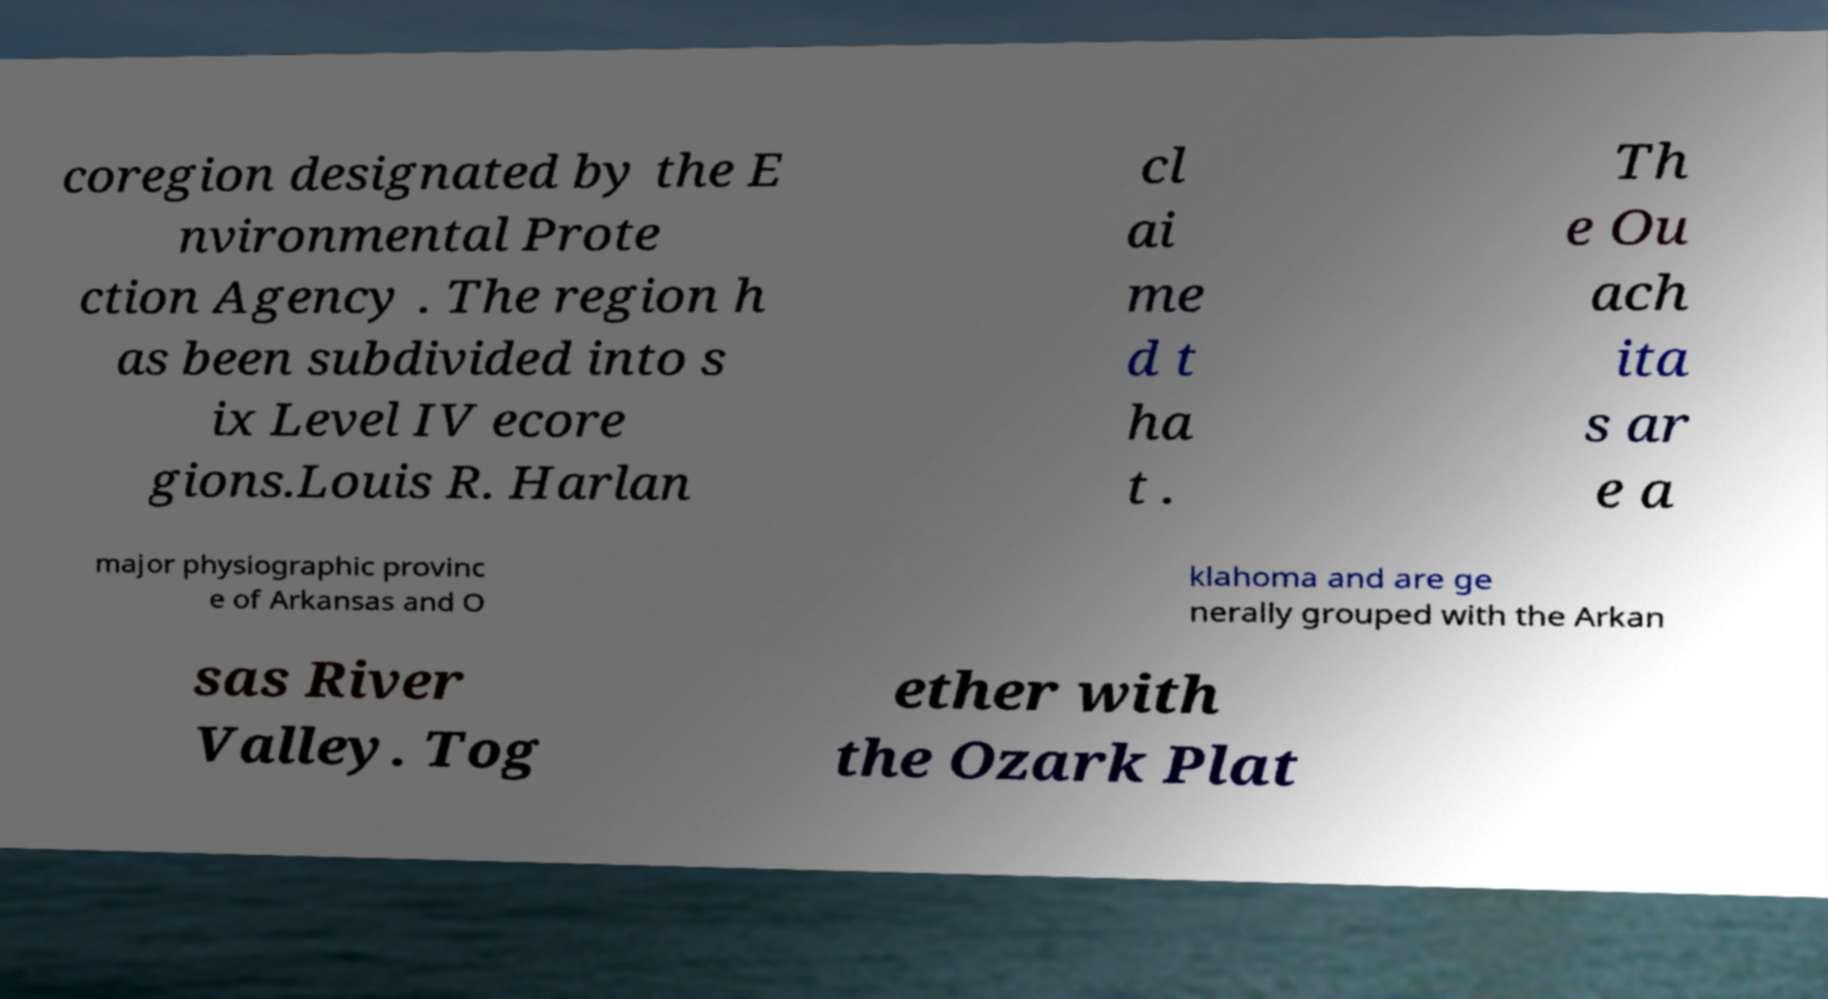Could you assist in decoding the text presented in this image and type it out clearly? coregion designated by the E nvironmental Prote ction Agency . The region h as been subdivided into s ix Level IV ecore gions.Louis R. Harlan cl ai me d t ha t . Th e Ou ach ita s ar e a major physiographic provinc e of Arkansas and O klahoma and are ge nerally grouped with the Arkan sas River Valley. Tog ether with the Ozark Plat 